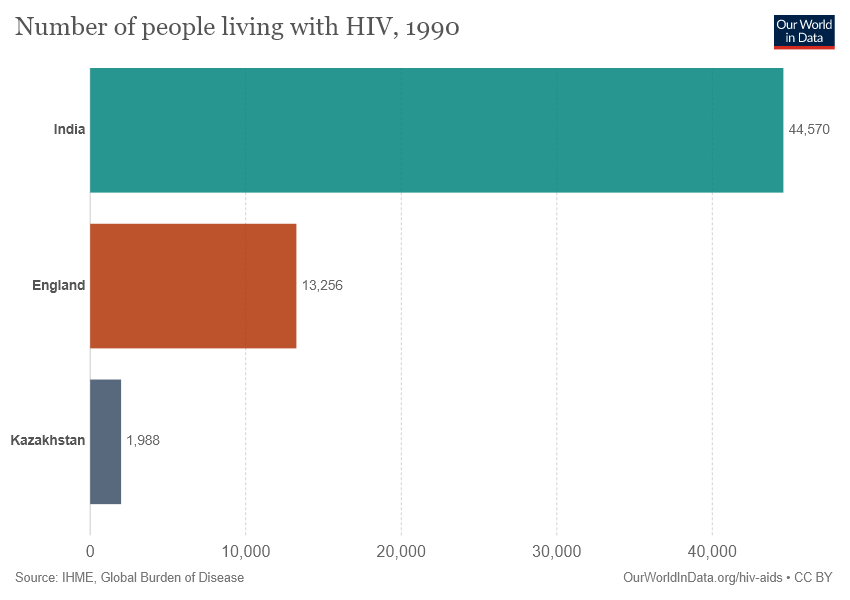Mention a couple of crucial points in this snapshot. India is represented by the uppermost bar in the stacked bar chart. The smallest two bars have a difference in value of 11268. 